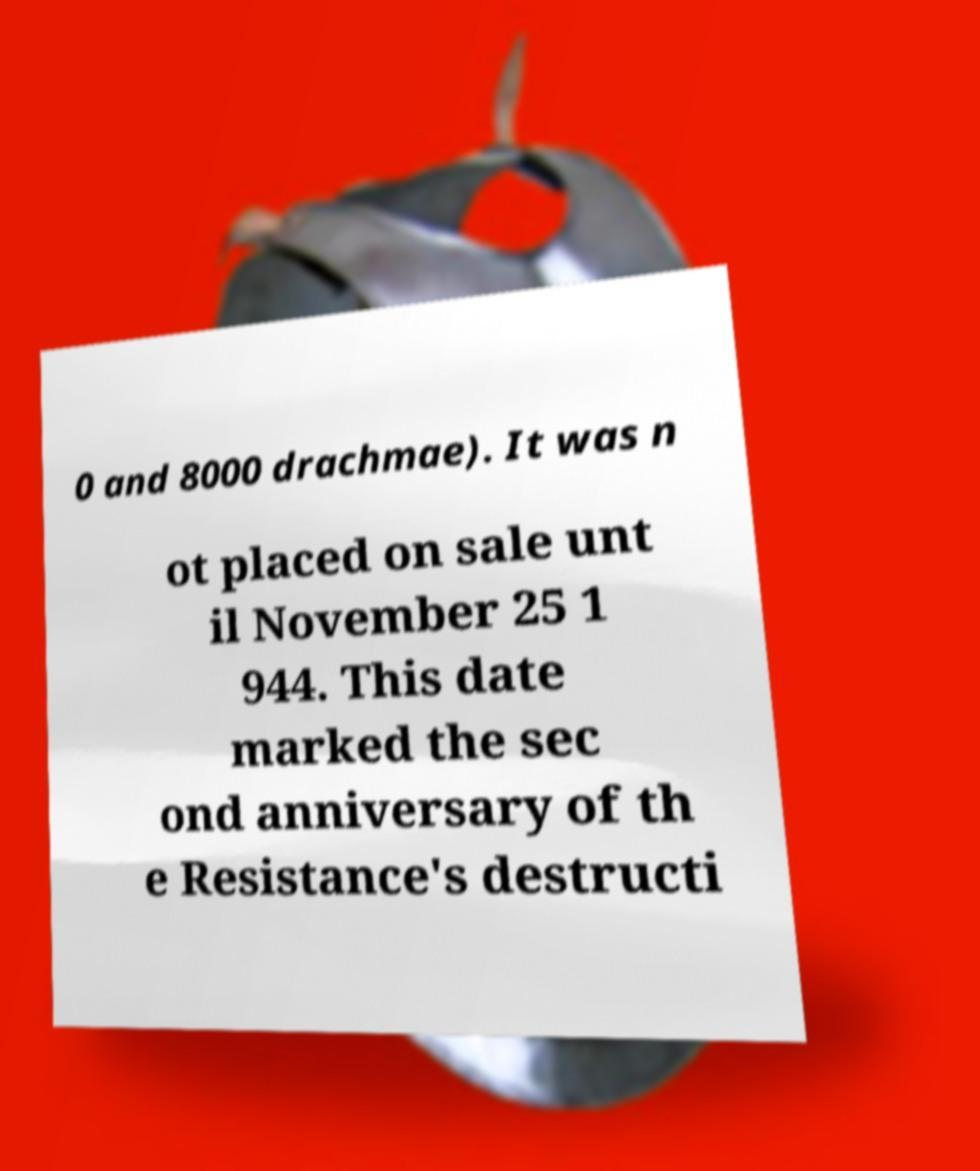Please read and relay the text visible in this image. What does it say? 0 and 8000 drachmae). It was n ot placed on sale unt il November 25 1 944. This date marked the sec ond anniversary of th e Resistance's destructi 